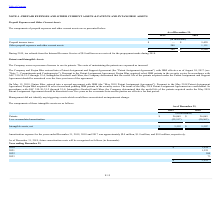From Finjan Holding's financial document, What are the respective values of patents in 2019 and 2018? The document shows two values: $26,069 and $26,069 (in thousands). From the document: "Patents $ 26,069 $ 26,069..." Also, What are the respective values of accumulated patent amortization in 2019 and 2018? The document shows two values: 22,517 and 20,562 (in thousands). From the document: "Less accumulated amortization (22,517) (20,562) Less accumulated amortization (22,517) (20,562)..." Also, What are the respective values of net intangible assets in 2019 and 2018? The document shows two values: $3,552 and $5,507 (in thousands). From the document: "Intangible assets, net $ 3,552 $ 5,507 Intangible assets, net $ 3,552 $ 5,507..." Also, can you calculate: What is the percentage change in the value of patents between 2018 and 2019? I cannot find a specific answer to this question in the financial document. Also, can you calculate: What is the percentage change in the value of net intangible assets between 2018 and 2019? To answer this question, I need to perform calculations using the financial data. The calculation is: (3,552 - 5,507)/5,507 , which equals -35.5 (percentage). This is based on the information: "Intangible assets, net $ 3,552 $ 5,507 Intangible assets, net $ 3,552 $ 5,507..." The key data points involved are: 3,552, 5,507. Also, can you calculate: What is the change in net intangible assets between 2018 and 2019? Based on the calculation: 5,507-3,552, the result is 1955 (in thousands). This is based on the information: "Intangible assets, net $ 3,552 $ 5,507 Intangible assets, net $ 3,552 $ 5,507..." The key data points involved are: 3,552, 5,507. 